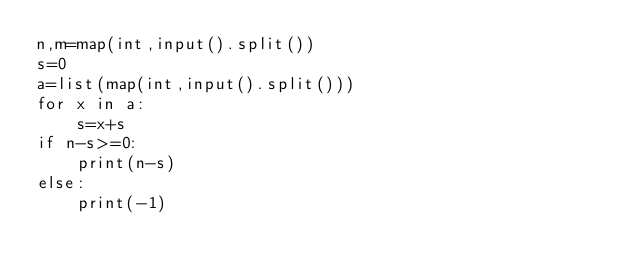Convert code to text. <code><loc_0><loc_0><loc_500><loc_500><_Python_>n,m=map(int,input().split())
s=0
a=list(map(int,input().split()))
for x in a:
    s=x+s
if n-s>=0:
    print(n-s)
else:
    print(-1)
    </code> 